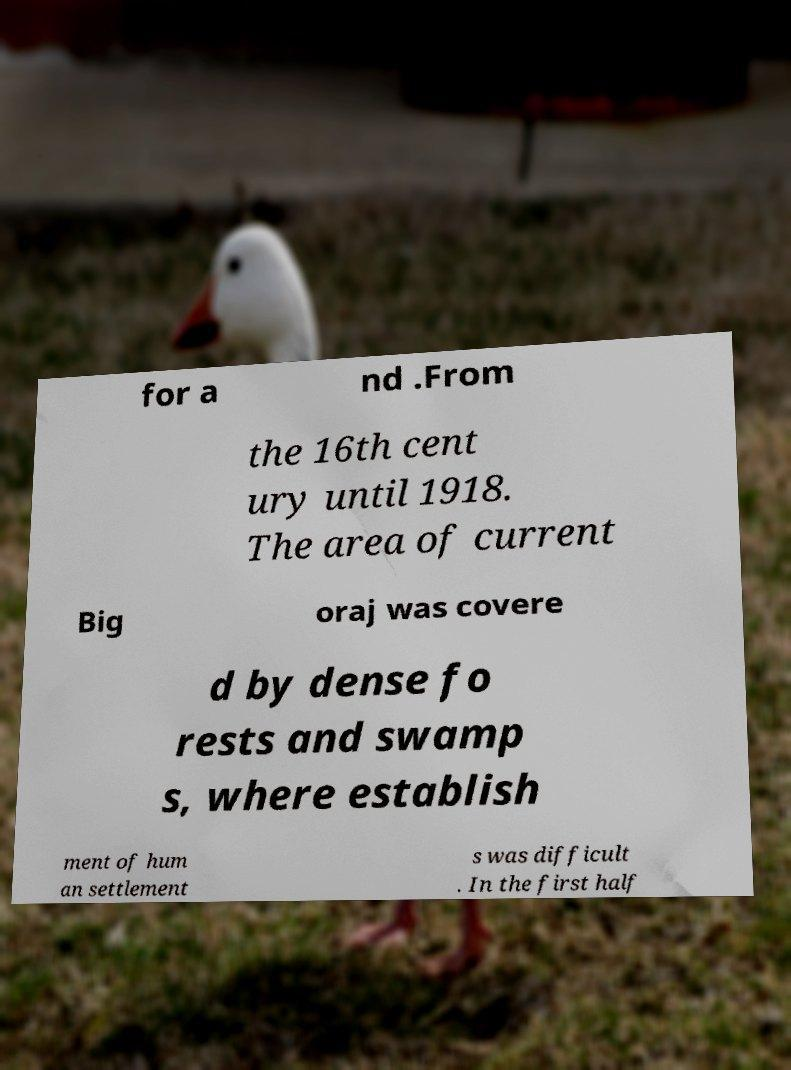There's text embedded in this image that I need extracted. Can you transcribe it verbatim? for a nd .From the 16th cent ury until 1918. The area of current Big oraj was covere d by dense fo rests and swamp s, where establish ment of hum an settlement s was difficult . In the first half 